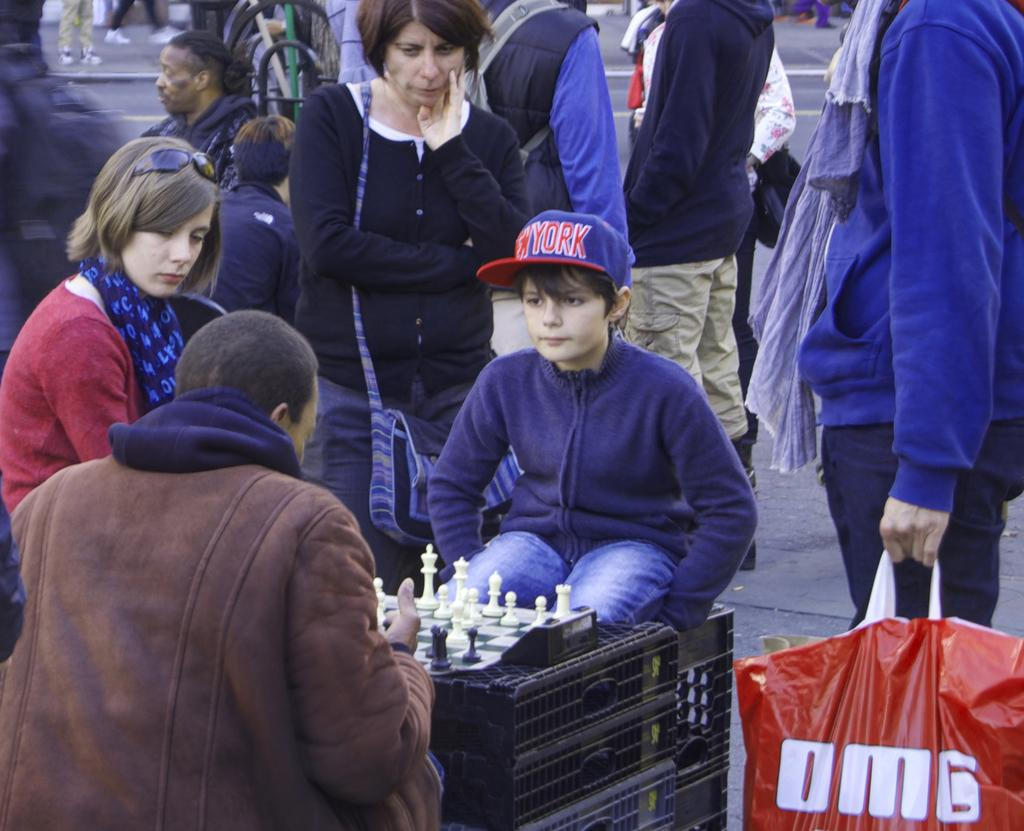What is happening on the road in the image? There are many people on the road in the image. Can you identify any specific activity being performed by some of the people? Yes, two people are playing chess in the image. What time of day is it in the image, considering the presence of the morning sun? There is no mention of the sun or any specific time of day in the image, so it cannot be determined from the image alone. 